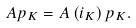Convert formula to latex. <formula><loc_0><loc_0><loc_500><loc_500>A p _ { K } = A \left ( i _ { K } \right ) p _ { K } .</formula> 